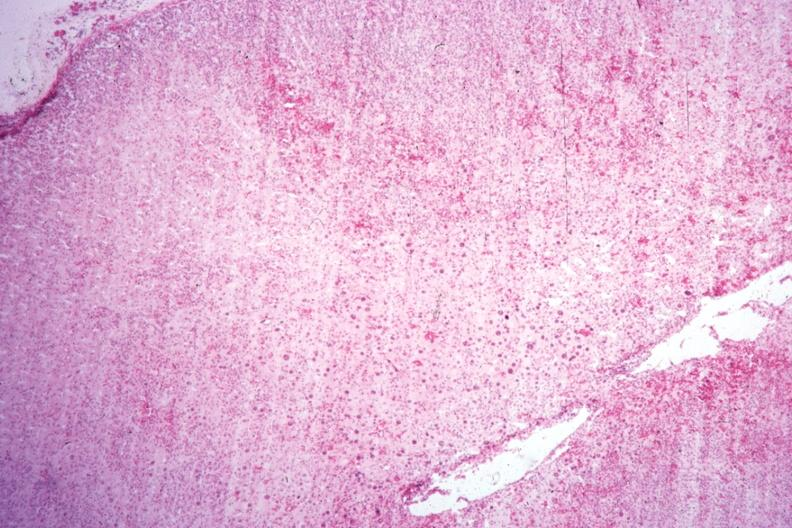s adrenal present?
Answer the question using a single word or phrase. Yes 